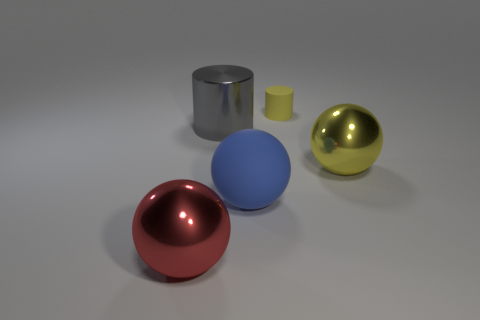Is there anything else that has the same size as the yellow matte cylinder?
Keep it short and to the point. No. What size is the ball that is the same color as the tiny cylinder?
Provide a short and direct response. Large. What number of balls are either green shiny objects or tiny matte things?
Your response must be concise. 0. The big cylinder is what color?
Give a very brief answer. Gray. There is a yellow object that is to the right of the yellow rubber cylinder; is its size the same as the rubber thing in front of the yellow cylinder?
Offer a terse response. Yes. Are there fewer big blue matte things than shiny balls?
Your response must be concise. Yes. What number of big cylinders are on the left side of the large shiny cylinder?
Your answer should be very brief. 0. What is the tiny yellow thing made of?
Your response must be concise. Rubber. Is the number of objects in front of the red sphere less than the number of large metal balls?
Give a very brief answer. Yes. What color is the rubber object behind the yellow metallic ball?
Provide a short and direct response. Yellow. 